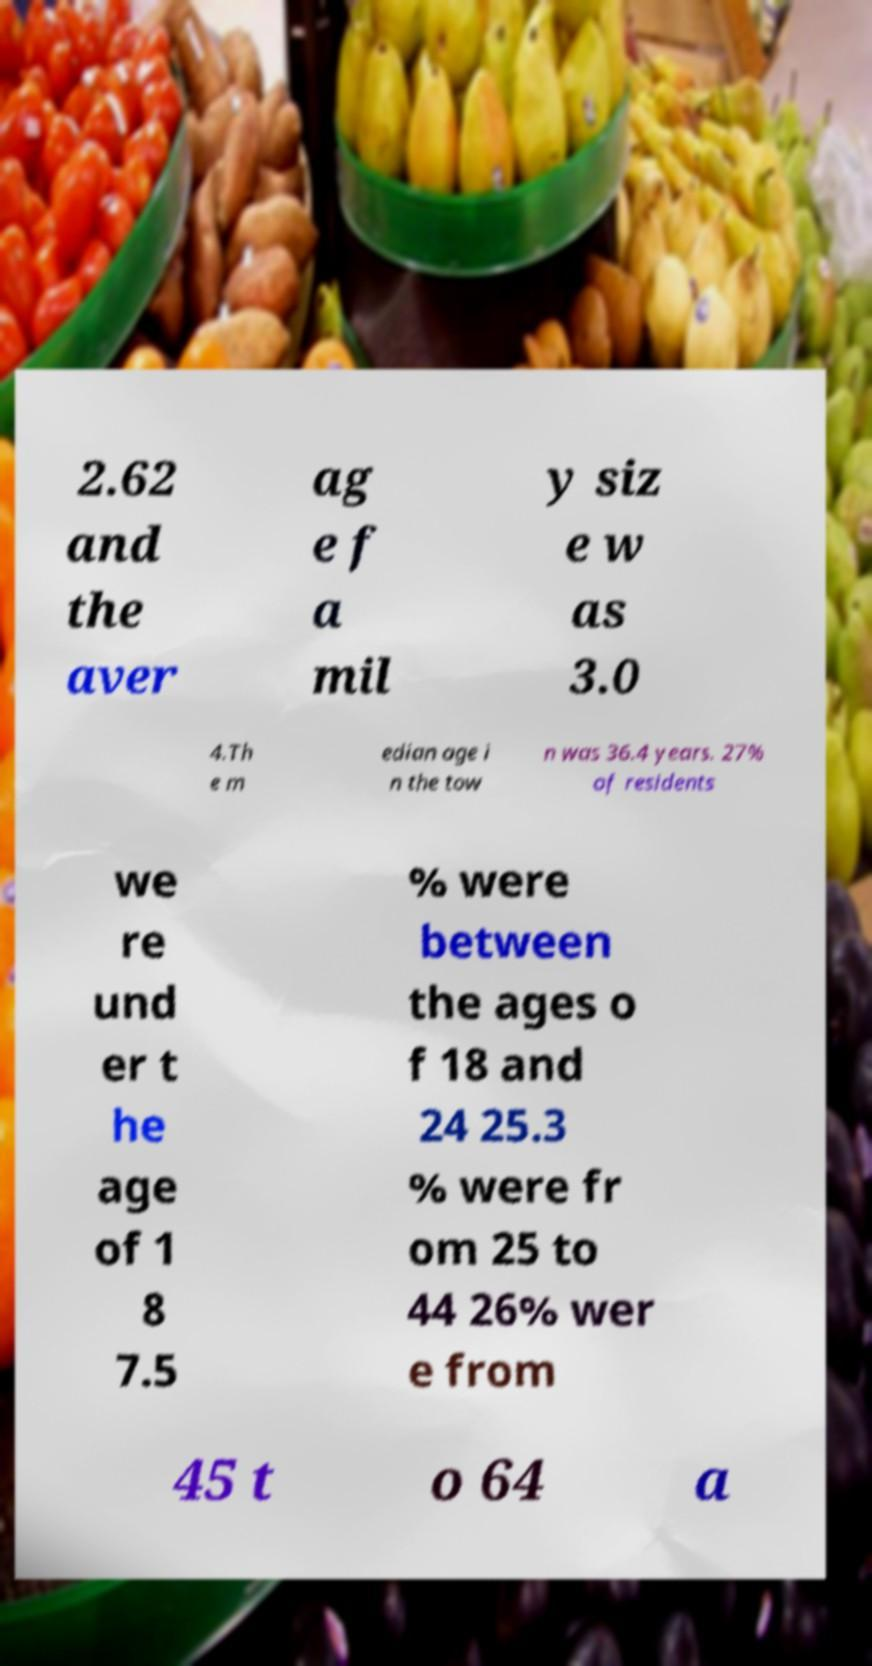Could you extract and type out the text from this image? 2.62 and the aver ag e f a mil y siz e w as 3.0 4.Th e m edian age i n the tow n was 36.4 years. 27% of residents we re und er t he age of 1 8 7.5 % were between the ages o f 18 and 24 25.3 % were fr om 25 to 44 26% wer e from 45 t o 64 a 